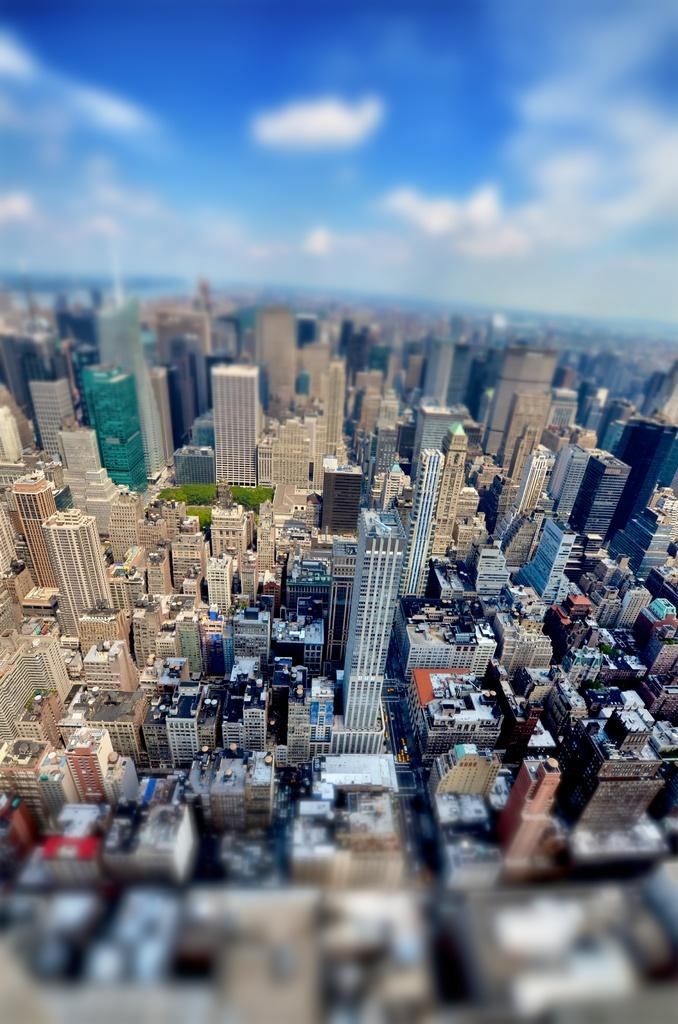What type of structures can be seen in the image? There are many buildings in the image. What else is visible besides buildings? There are vehicles, trees, and roads in the image. Can you describe the view at the top and bottom of the image? The bottom and top of the image have a blurred view. What is visible at the top of the image? The sky is visible at the top of the image. What type of seed is growing in the room in the image? There is no seed or room present in the image. What is the downtown area like in the image? The image does not depict a downtown area; it shows buildings, vehicles, trees, and roads. 